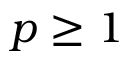<formula> <loc_0><loc_0><loc_500><loc_500>p \geq 1</formula> 